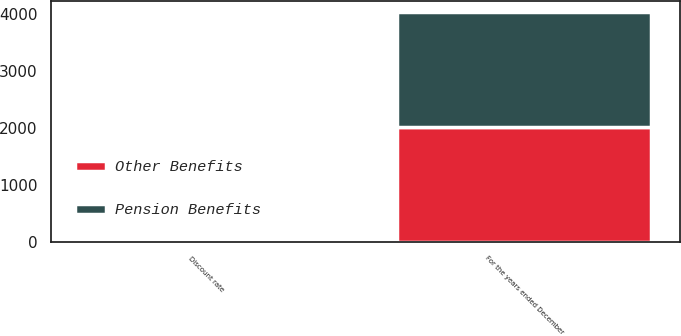<chart> <loc_0><loc_0><loc_500><loc_500><stacked_bar_chart><ecel><fcel>For the years ended December<fcel>Discount rate<nl><fcel>Other Benefits<fcel>2017<fcel>3.8<nl><fcel>Pension Benefits<fcel>2017<fcel>3.8<nl></chart> 